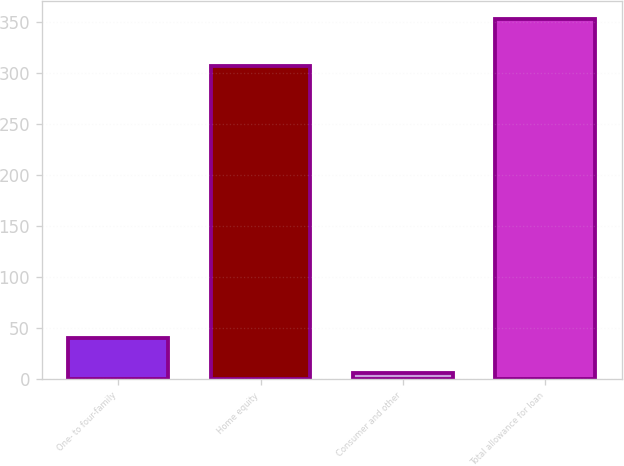Convert chart. <chart><loc_0><loc_0><loc_500><loc_500><bar_chart><fcel>One- to four-family<fcel>Home equity<fcel>Consumer and other<fcel>Total allowance for loan<nl><fcel>40.7<fcel>307<fcel>6<fcel>353<nl></chart> 